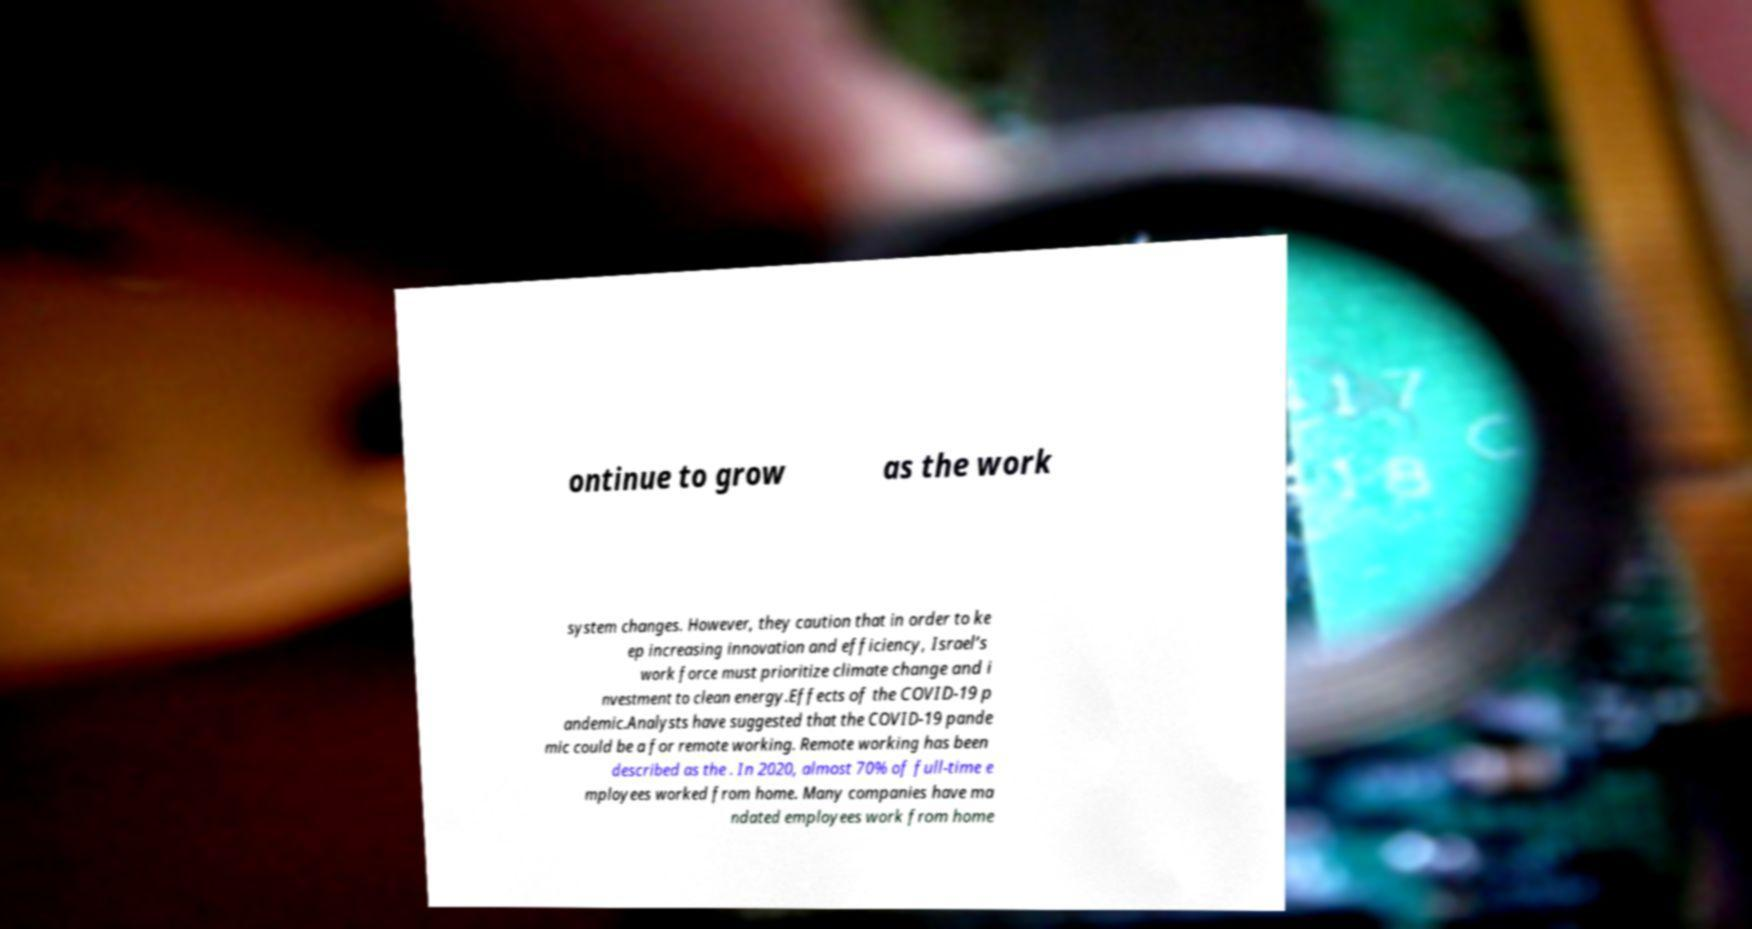Can you read and provide the text displayed in the image?This photo seems to have some interesting text. Can you extract and type it out for me? ontinue to grow as the work system changes. However, they caution that in order to ke ep increasing innovation and efficiency, Israel’s work force must prioritize climate change and i nvestment to clean energy.Effects of the COVID-19 p andemic.Analysts have suggested that the COVID-19 pande mic could be a for remote working. Remote working has been described as the . In 2020, almost 70% of full-time e mployees worked from home. Many companies have ma ndated employees work from home 